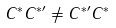<formula> <loc_0><loc_0><loc_500><loc_500>C ^ { \ast } C ^ { \ast \prime } \neq C ^ { \ast \prime } C ^ { \ast }</formula> 